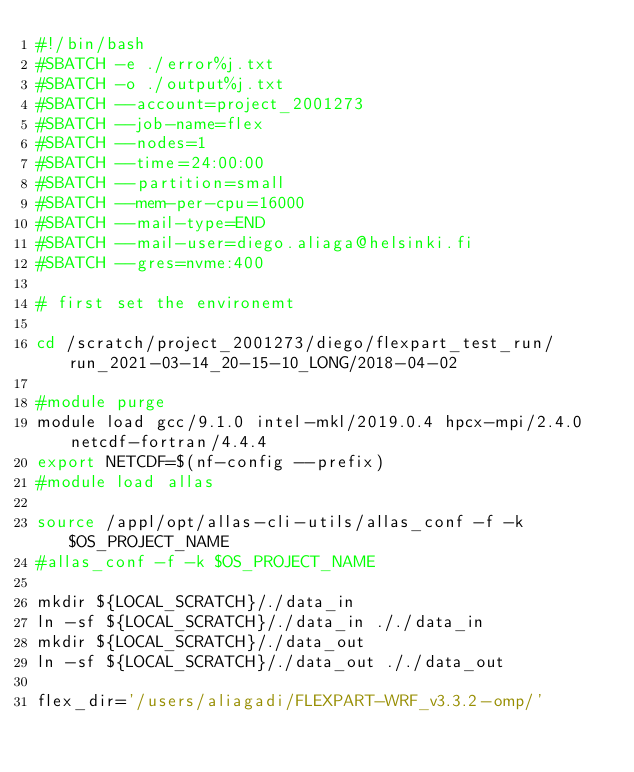<code> <loc_0><loc_0><loc_500><loc_500><_Bash_>#!/bin/bash
#SBATCH -e ./error%j.txt
#SBATCH -o ./output%j.txt
#SBATCH --account=project_2001273
#SBATCH --job-name=flex
#SBATCH --nodes=1
#SBATCH --time=24:00:00
#SBATCH --partition=small
#SBATCH --mem-per-cpu=16000
#SBATCH --mail-type=END
#SBATCH --mail-user=diego.aliaga@helsinki.fi
#SBATCH --gres=nvme:400

# first set the environemt

cd /scratch/project_2001273/diego/flexpart_test_run/run_2021-03-14_20-15-10_LONG/2018-04-02

#module purge
module load gcc/9.1.0 intel-mkl/2019.0.4 hpcx-mpi/2.4.0 netcdf-fortran/4.4.4
export NETCDF=$(nf-config --prefix)
#module load allas

source /appl/opt/allas-cli-utils/allas_conf -f -k $OS_PROJECT_NAME
#allas_conf -f -k $OS_PROJECT_NAME

mkdir ${LOCAL_SCRATCH}/./data_in
ln -sf ${LOCAL_SCRATCH}/./data_in ././data_in
mkdir ${LOCAL_SCRATCH}/./data_out
ln -sf ${LOCAL_SCRATCH}/./data_out ././data_out

flex_dir='/users/aliagadi/FLEXPART-WRF_v3.3.2-omp/'</code> 